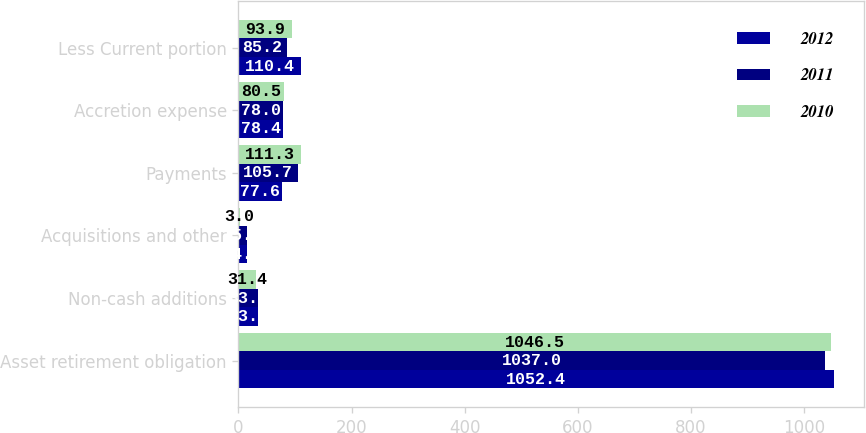Convert chart to OTSL. <chart><loc_0><loc_0><loc_500><loc_500><stacked_bar_chart><ecel><fcel>Asset retirement obligation<fcel>Non-cash additions<fcel>Acquisitions and other<fcel>Payments<fcel>Accretion expense<fcel>Less Current portion<nl><fcel>2012<fcel>1052.4<fcel>33.8<fcel>14.6<fcel>77.6<fcel>78.4<fcel>110.4<nl><fcel>2011<fcel>1037<fcel>33.9<fcel>15.8<fcel>105.7<fcel>78<fcel>85.2<nl><fcel>2010<fcel>1046.5<fcel>31.4<fcel>3<fcel>111.3<fcel>80.5<fcel>93.9<nl></chart> 